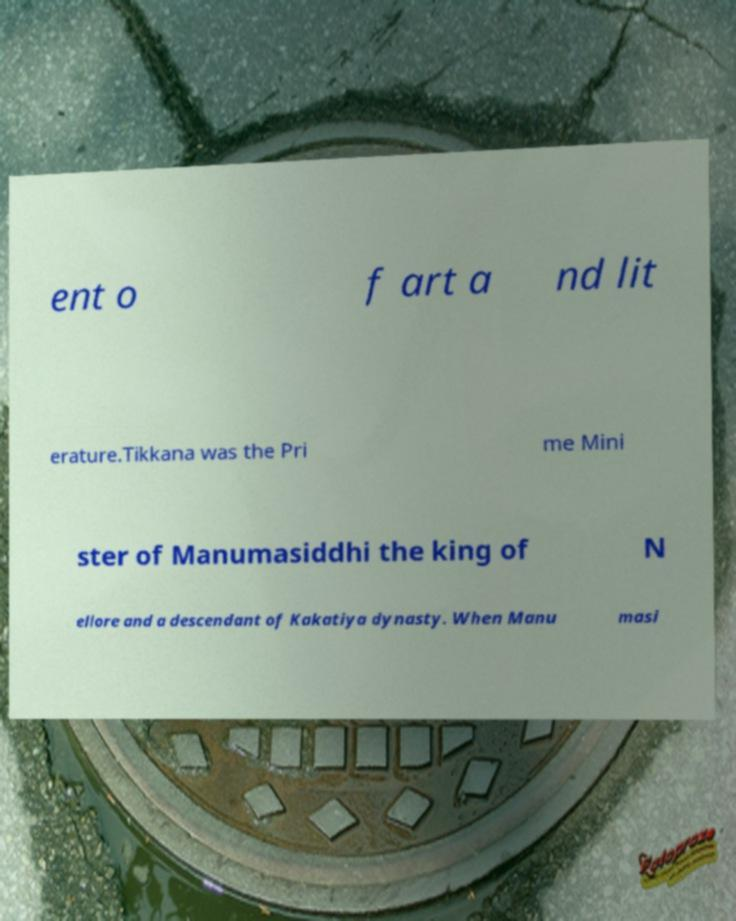What messages or text are displayed in this image? I need them in a readable, typed format. ent o f art a nd lit erature.Tikkana was the Pri me Mini ster of Manumasiddhi the king of N ellore and a descendant of Kakatiya dynasty. When Manu masi 